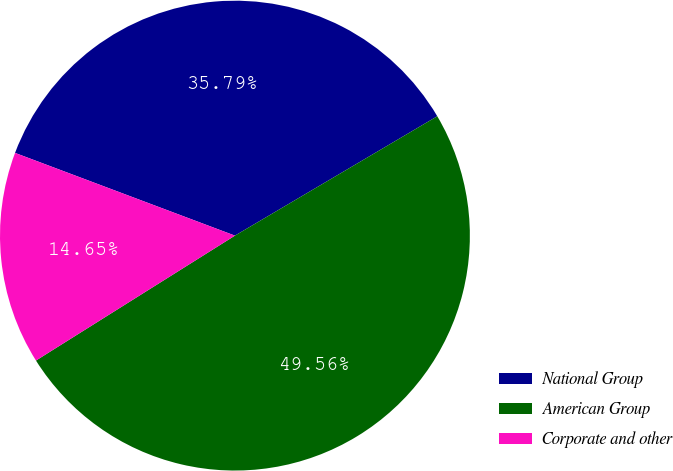Convert chart. <chart><loc_0><loc_0><loc_500><loc_500><pie_chart><fcel>National Group<fcel>American Group<fcel>Corporate and other<nl><fcel>35.79%<fcel>49.56%<fcel>14.65%<nl></chart> 